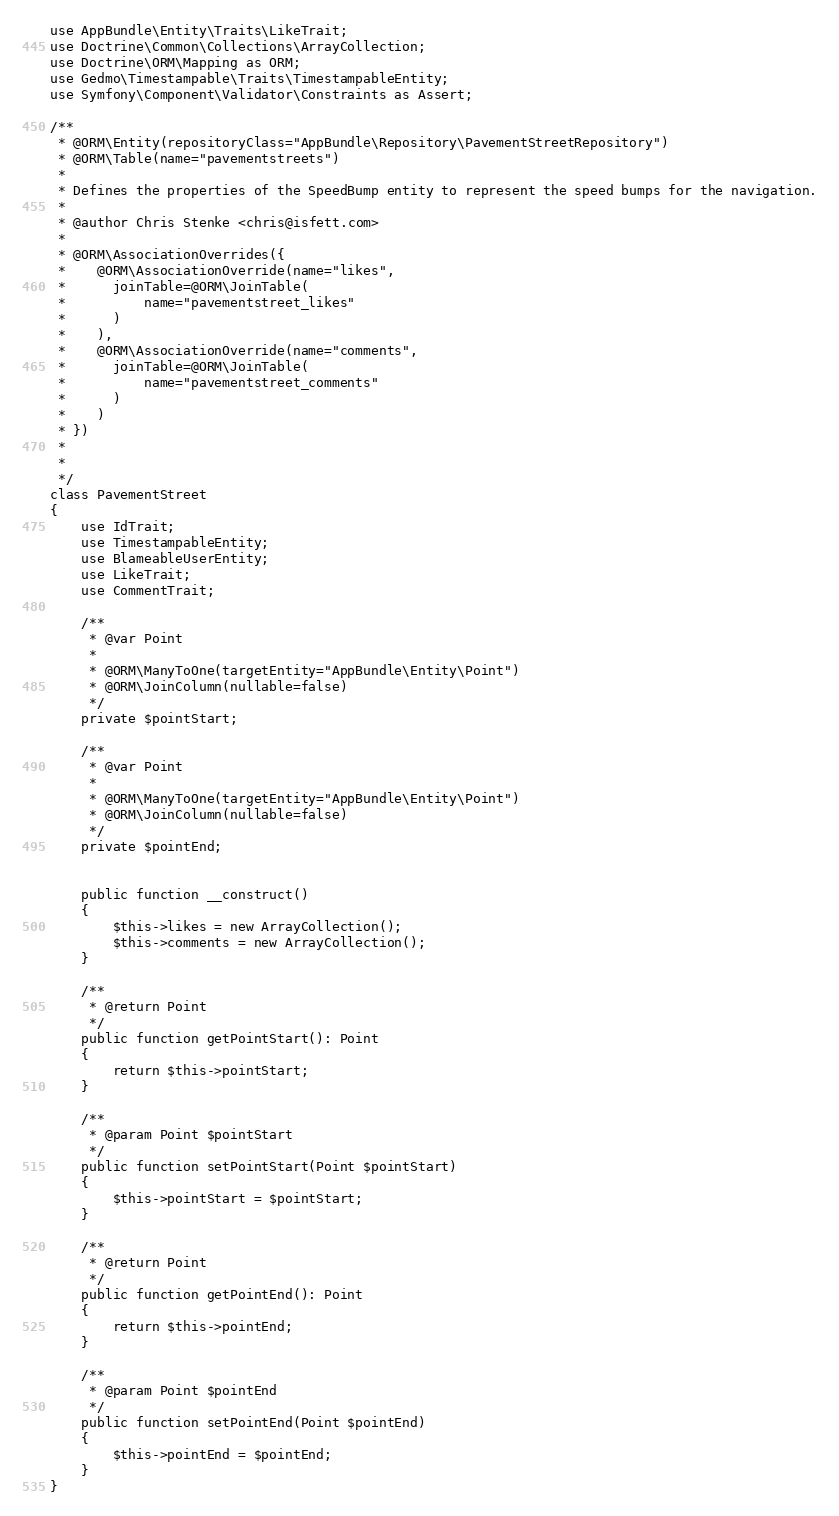<code> <loc_0><loc_0><loc_500><loc_500><_PHP_>use AppBundle\Entity\Traits\LikeTrait;
use Doctrine\Common\Collections\ArrayCollection;
use Doctrine\ORM\Mapping as ORM;
use Gedmo\Timestampable\Traits\TimestampableEntity;
use Symfony\Component\Validator\Constraints as Assert;

/**
 * @ORM\Entity(repositoryClass="AppBundle\Repository\PavementStreetRepository")
 * @ORM\Table(name="pavementstreets")
 *
 * Defines the properties of the SpeedBump entity to represent the speed bumps for the navigation.
 *
 * @author Chris Stenke <chris@isfett.com>
 *
 * @ORM\AssociationOverrides({
 *    @ORM\AssociationOverride(name="likes",
 *      joinTable=@ORM\JoinTable(
 *          name="pavementstreet_likes"
 *      )
 *    ),
 *    @ORM\AssociationOverride(name="comments",
 *      joinTable=@ORM\JoinTable(
 *          name="pavementstreet_comments"
 *      )
 *    )
 * })
 *
 *
 */
class PavementStreet
{
    use IdTrait;
    use TimestampableEntity;
    use BlameableUserEntity;
    use LikeTrait;
    use CommentTrait;

    /**
     * @var Point
     *
     * @ORM\ManyToOne(targetEntity="AppBundle\Entity\Point")
     * @ORM\JoinColumn(nullable=false)
     */
    private $pointStart;

    /**
     * @var Point
     *
     * @ORM\ManyToOne(targetEntity="AppBundle\Entity\Point")
     * @ORM\JoinColumn(nullable=false)
     */
    private $pointEnd;


    public function __construct()
    {
        $this->likes = new ArrayCollection();
        $this->comments = new ArrayCollection();
    }

    /**
     * @return Point
     */
    public function getPointStart(): Point
    {
        return $this->pointStart;
    }

    /**
     * @param Point $pointStart
     */
    public function setPointStart(Point $pointStart)
    {
        $this->pointStart = $pointStart;
    }

    /**
     * @return Point
     */
    public function getPointEnd(): Point
    {
        return $this->pointEnd;
    }

    /**
     * @param Point $pointEnd
     */
    public function setPointEnd(Point $pointEnd)
    {
        $this->pointEnd = $pointEnd;
    }
}
</code> 